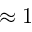Convert formula to latex. <formula><loc_0><loc_0><loc_500><loc_500>\approx 1</formula> 